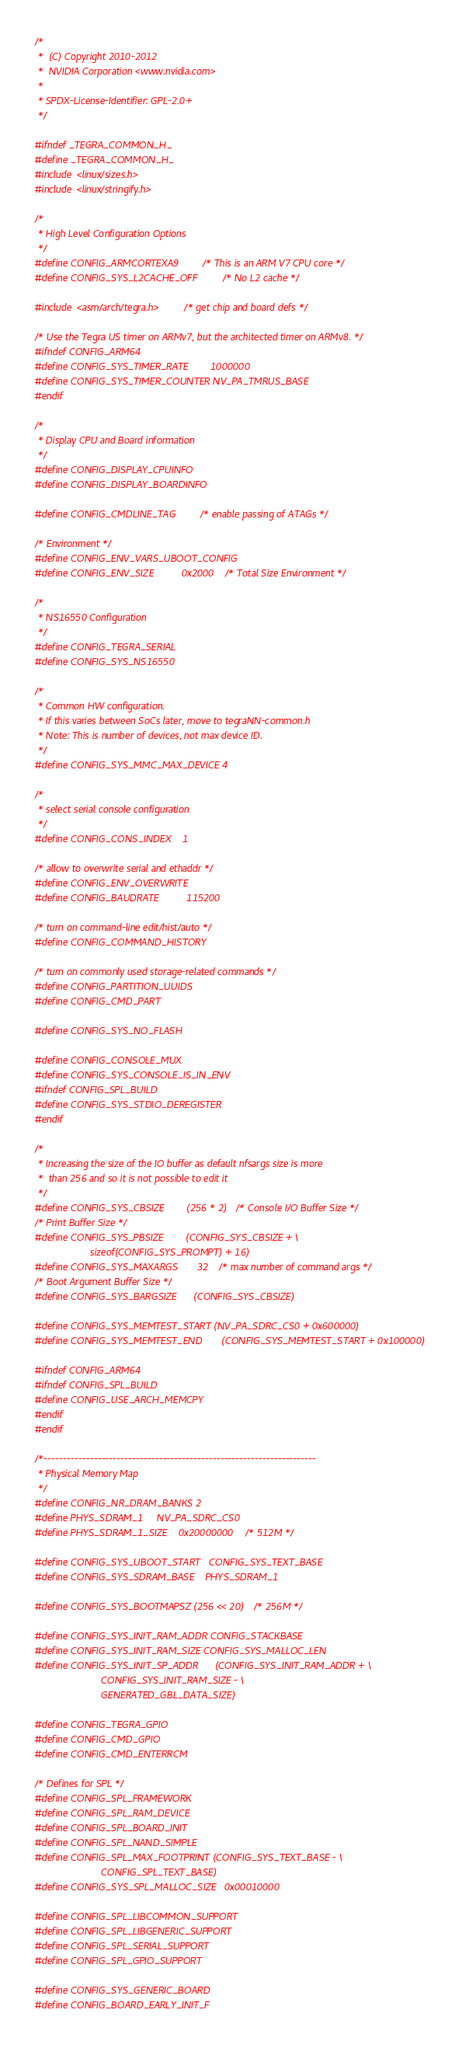Convert code to text. <code><loc_0><loc_0><loc_500><loc_500><_C_>/*
 *  (C) Copyright 2010-2012
 *  NVIDIA Corporation <www.nvidia.com>
 *
 * SPDX-License-Identifier:	GPL-2.0+
 */

#ifndef _TEGRA_COMMON_H_
#define _TEGRA_COMMON_H_
#include <linux/sizes.h>
#include <linux/stringify.h>

/*
 * High Level Configuration Options
 */
#define CONFIG_ARMCORTEXA9		/* This is an ARM V7 CPU core */
#define CONFIG_SYS_L2CACHE_OFF		/* No L2 cache */

#include <asm/arch/tegra.h>		/* get chip and board defs */

/* Use the Tegra US timer on ARMv7, but the architected timer on ARMv8. */
#ifndef CONFIG_ARM64
#define CONFIG_SYS_TIMER_RATE		1000000
#define CONFIG_SYS_TIMER_COUNTER	NV_PA_TMRUS_BASE
#endif

/*
 * Display CPU and Board information
 */
#define CONFIG_DISPLAY_CPUINFO
#define CONFIG_DISPLAY_BOARDINFO

#define CONFIG_CMDLINE_TAG		/* enable passing of ATAGs */

/* Environment */
#define CONFIG_ENV_VARS_UBOOT_CONFIG
#define CONFIG_ENV_SIZE			0x2000	/* Total Size Environment */

/*
 * NS16550 Configuration
 */
#define CONFIG_TEGRA_SERIAL
#define CONFIG_SYS_NS16550

/*
 * Common HW configuration.
 * If this varies between SoCs later, move to tegraNN-common.h
 * Note: This is number of devices, not max device ID.
 */
#define CONFIG_SYS_MMC_MAX_DEVICE 4

/*
 * select serial console configuration
 */
#define CONFIG_CONS_INDEX	1

/* allow to overwrite serial and ethaddr */
#define CONFIG_ENV_OVERWRITE
#define CONFIG_BAUDRATE			115200

/* turn on command-line edit/hist/auto */
#define CONFIG_COMMAND_HISTORY

/* turn on commonly used storage-related commands */
#define CONFIG_PARTITION_UUIDS
#define CONFIG_CMD_PART

#define CONFIG_SYS_NO_FLASH

#define CONFIG_CONSOLE_MUX
#define CONFIG_SYS_CONSOLE_IS_IN_ENV
#ifndef CONFIG_SPL_BUILD
#define CONFIG_SYS_STDIO_DEREGISTER
#endif

/*
 * Increasing the size of the IO buffer as default nfsargs size is more
 *  than 256 and so it is not possible to edit it
 */
#define CONFIG_SYS_CBSIZE		(256 * 2) /* Console I/O Buffer Size */
/* Print Buffer Size */
#define CONFIG_SYS_PBSIZE		(CONFIG_SYS_CBSIZE + \
					sizeof(CONFIG_SYS_PROMPT) + 16)
#define CONFIG_SYS_MAXARGS		32	/* max number of command args */
/* Boot Argument Buffer Size */
#define CONFIG_SYS_BARGSIZE		(CONFIG_SYS_CBSIZE)

#define CONFIG_SYS_MEMTEST_START	(NV_PA_SDRC_CS0 + 0x600000)
#define CONFIG_SYS_MEMTEST_END		(CONFIG_SYS_MEMTEST_START + 0x100000)

#ifndef CONFIG_ARM64
#ifndef CONFIG_SPL_BUILD
#define CONFIG_USE_ARCH_MEMCPY
#endif
#endif

/*-----------------------------------------------------------------------
 * Physical Memory Map
 */
#define CONFIG_NR_DRAM_BANKS	2
#define PHYS_SDRAM_1		NV_PA_SDRC_CS0
#define PHYS_SDRAM_1_SIZE	0x20000000	/* 512M */

#define CONFIG_SYS_UBOOT_START	CONFIG_SYS_TEXT_BASE
#define CONFIG_SYS_SDRAM_BASE	PHYS_SDRAM_1

#define CONFIG_SYS_BOOTMAPSZ	(256 << 20)	/* 256M */

#define CONFIG_SYS_INIT_RAM_ADDR	CONFIG_STACKBASE
#define CONFIG_SYS_INIT_RAM_SIZE	CONFIG_SYS_MALLOC_LEN
#define CONFIG_SYS_INIT_SP_ADDR		(CONFIG_SYS_INIT_RAM_ADDR + \
						CONFIG_SYS_INIT_RAM_SIZE - \
						GENERATED_GBL_DATA_SIZE)

#define CONFIG_TEGRA_GPIO
#define CONFIG_CMD_GPIO
#define CONFIG_CMD_ENTERRCM

/* Defines for SPL */
#define CONFIG_SPL_FRAMEWORK
#define CONFIG_SPL_RAM_DEVICE
#define CONFIG_SPL_BOARD_INIT
#define CONFIG_SPL_NAND_SIMPLE
#define CONFIG_SPL_MAX_FOOTPRINT	(CONFIG_SYS_TEXT_BASE - \
						CONFIG_SPL_TEXT_BASE)
#define CONFIG_SYS_SPL_MALLOC_SIZE	0x00010000

#define CONFIG_SPL_LIBCOMMON_SUPPORT
#define CONFIG_SPL_LIBGENERIC_SUPPORT
#define CONFIG_SPL_SERIAL_SUPPORT
#define CONFIG_SPL_GPIO_SUPPORT

#define CONFIG_SYS_GENERIC_BOARD
#define CONFIG_BOARD_EARLY_INIT_F</code> 